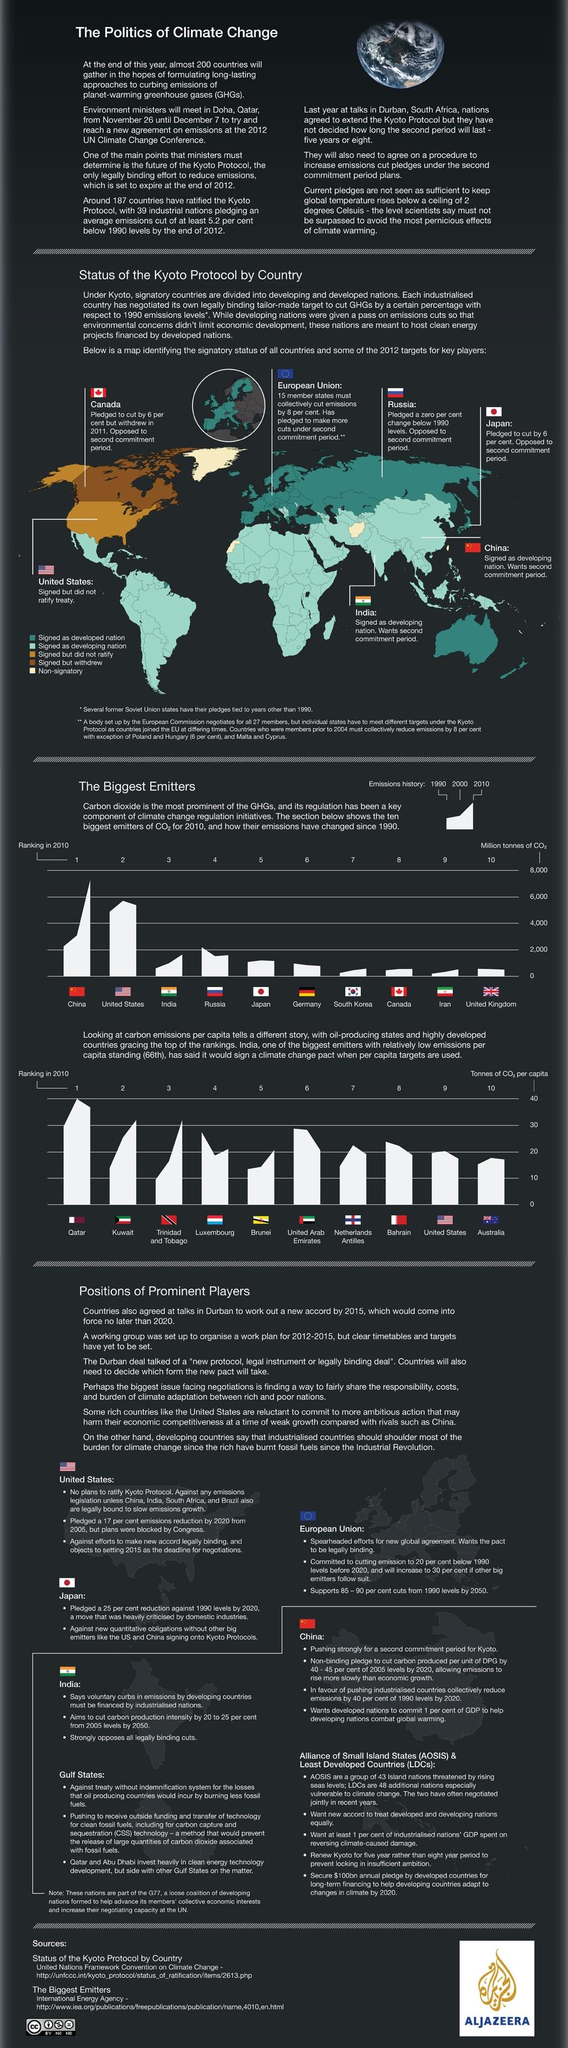Identify some key points in this picture. Canada signed the Kyoto Protocol but later withdrew from it. The 2012 UN Climate Change Conference was held in Doha, Qatar. Australia has signed as a developed nation based on the color code in the map. Japan is the Asian island country that opposes the second commitment period. The CO2 emission history of India shows that the highest emissions were recorded in 2010. 